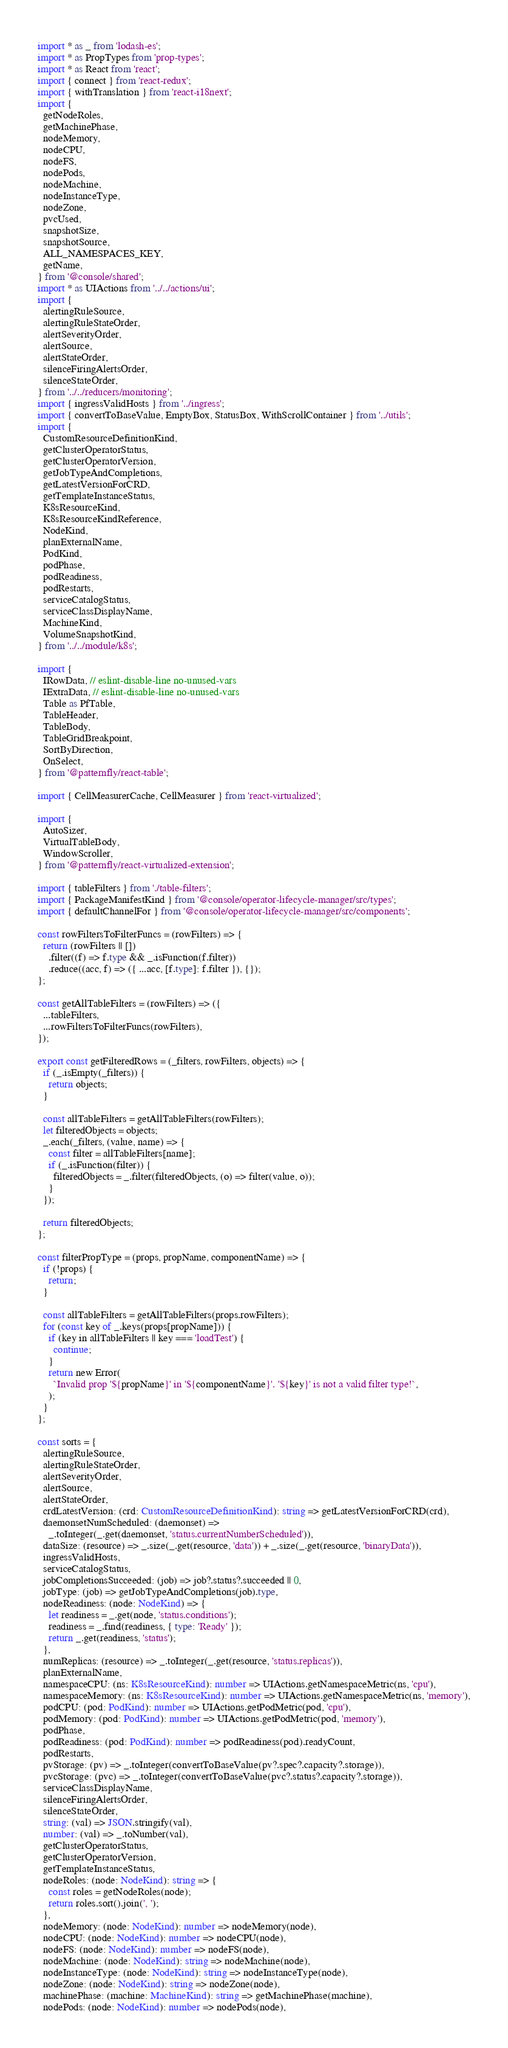Convert code to text. <code><loc_0><loc_0><loc_500><loc_500><_TypeScript_>import * as _ from 'lodash-es';
import * as PropTypes from 'prop-types';
import * as React from 'react';
import { connect } from 'react-redux';
import { withTranslation } from 'react-i18next';
import {
  getNodeRoles,
  getMachinePhase,
  nodeMemory,
  nodeCPU,
  nodeFS,
  nodePods,
  nodeMachine,
  nodeInstanceType,
  nodeZone,
  pvcUsed,
  snapshotSize,
  snapshotSource,
  ALL_NAMESPACES_KEY,
  getName,
} from '@console/shared';
import * as UIActions from '../../actions/ui';
import {
  alertingRuleSource,
  alertingRuleStateOrder,
  alertSeverityOrder,
  alertSource,
  alertStateOrder,
  silenceFiringAlertsOrder,
  silenceStateOrder,
} from '../../reducers/monitoring';
import { ingressValidHosts } from '../ingress';
import { convertToBaseValue, EmptyBox, StatusBox, WithScrollContainer } from '../utils';
import {
  CustomResourceDefinitionKind,
  getClusterOperatorStatus,
  getClusterOperatorVersion,
  getJobTypeAndCompletions,
  getLatestVersionForCRD,
  getTemplateInstanceStatus,
  K8sResourceKind,
  K8sResourceKindReference,
  NodeKind,
  planExternalName,
  PodKind,
  podPhase,
  podReadiness,
  podRestarts,
  serviceCatalogStatus,
  serviceClassDisplayName,
  MachineKind,
  VolumeSnapshotKind,
} from '../../module/k8s';

import {
  IRowData, // eslint-disable-line no-unused-vars
  IExtraData, // eslint-disable-line no-unused-vars
  Table as PfTable,
  TableHeader,
  TableBody,
  TableGridBreakpoint,
  SortByDirection,
  OnSelect,
} from '@patternfly/react-table';

import { CellMeasurerCache, CellMeasurer } from 'react-virtualized';

import {
  AutoSizer,
  VirtualTableBody,
  WindowScroller,
} from '@patternfly/react-virtualized-extension';

import { tableFilters } from './table-filters';
import { PackageManifestKind } from '@console/operator-lifecycle-manager/src/types';
import { defaultChannelFor } from '@console/operator-lifecycle-manager/src/components';

const rowFiltersToFilterFuncs = (rowFilters) => {
  return (rowFilters || [])
    .filter((f) => f.type && _.isFunction(f.filter))
    .reduce((acc, f) => ({ ...acc, [f.type]: f.filter }), {});
};

const getAllTableFilters = (rowFilters) => ({
  ...tableFilters,
  ...rowFiltersToFilterFuncs(rowFilters),
});

export const getFilteredRows = (_filters, rowFilters, objects) => {
  if (_.isEmpty(_filters)) {
    return objects;
  }

  const allTableFilters = getAllTableFilters(rowFilters);
  let filteredObjects = objects;
  _.each(_filters, (value, name) => {
    const filter = allTableFilters[name];
    if (_.isFunction(filter)) {
      filteredObjects = _.filter(filteredObjects, (o) => filter(value, o));
    }
  });

  return filteredObjects;
};

const filterPropType = (props, propName, componentName) => {
  if (!props) {
    return;
  }

  const allTableFilters = getAllTableFilters(props.rowFilters);
  for (const key of _.keys(props[propName])) {
    if (key in allTableFilters || key === 'loadTest') {
      continue;
    }
    return new Error(
      `Invalid prop '${propName}' in '${componentName}'. '${key}' is not a valid filter type!`,
    );
  }
};

const sorts = {
  alertingRuleSource,
  alertingRuleStateOrder,
  alertSeverityOrder,
  alertSource,
  alertStateOrder,
  crdLatestVersion: (crd: CustomResourceDefinitionKind): string => getLatestVersionForCRD(crd),
  daemonsetNumScheduled: (daemonset) =>
    _.toInteger(_.get(daemonset, 'status.currentNumberScheduled')),
  dataSize: (resource) => _.size(_.get(resource, 'data')) + _.size(_.get(resource, 'binaryData')),
  ingressValidHosts,
  serviceCatalogStatus,
  jobCompletionsSucceeded: (job) => job?.status?.succeeded || 0,
  jobType: (job) => getJobTypeAndCompletions(job).type,
  nodeReadiness: (node: NodeKind) => {
    let readiness = _.get(node, 'status.conditions');
    readiness = _.find(readiness, { type: 'Ready' });
    return _.get(readiness, 'status');
  },
  numReplicas: (resource) => _.toInteger(_.get(resource, 'status.replicas')),
  planExternalName,
  namespaceCPU: (ns: K8sResourceKind): number => UIActions.getNamespaceMetric(ns, 'cpu'),
  namespaceMemory: (ns: K8sResourceKind): number => UIActions.getNamespaceMetric(ns, 'memory'),
  podCPU: (pod: PodKind): number => UIActions.getPodMetric(pod, 'cpu'),
  podMemory: (pod: PodKind): number => UIActions.getPodMetric(pod, 'memory'),
  podPhase,
  podReadiness: (pod: PodKind): number => podReadiness(pod).readyCount,
  podRestarts,
  pvStorage: (pv) => _.toInteger(convertToBaseValue(pv?.spec?.capacity?.storage)),
  pvcStorage: (pvc) => _.toInteger(convertToBaseValue(pvc?.status?.capacity?.storage)),
  serviceClassDisplayName,
  silenceFiringAlertsOrder,
  silenceStateOrder,
  string: (val) => JSON.stringify(val),
  number: (val) => _.toNumber(val),
  getClusterOperatorStatus,
  getClusterOperatorVersion,
  getTemplateInstanceStatus,
  nodeRoles: (node: NodeKind): string => {
    const roles = getNodeRoles(node);
    return roles.sort().join(', ');
  },
  nodeMemory: (node: NodeKind): number => nodeMemory(node),
  nodeCPU: (node: NodeKind): number => nodeCPU(node),
  nodeFS: (node: NodeKind): number => nodeFS(node),
  nodeMachine: (node: NodeKind): string => nodeMachine(node),
  nodeInstanceType: (node: NodeKind): string => nodeInstanceType(node),
  nodeZone: (node: NodeKind): string => nodeZone(node),
  machinePhase: (machine: MachineKind): string => getMachinePhase(machine),
  nodePods: (node: NodeKind): number => nodePods(node),</code> 